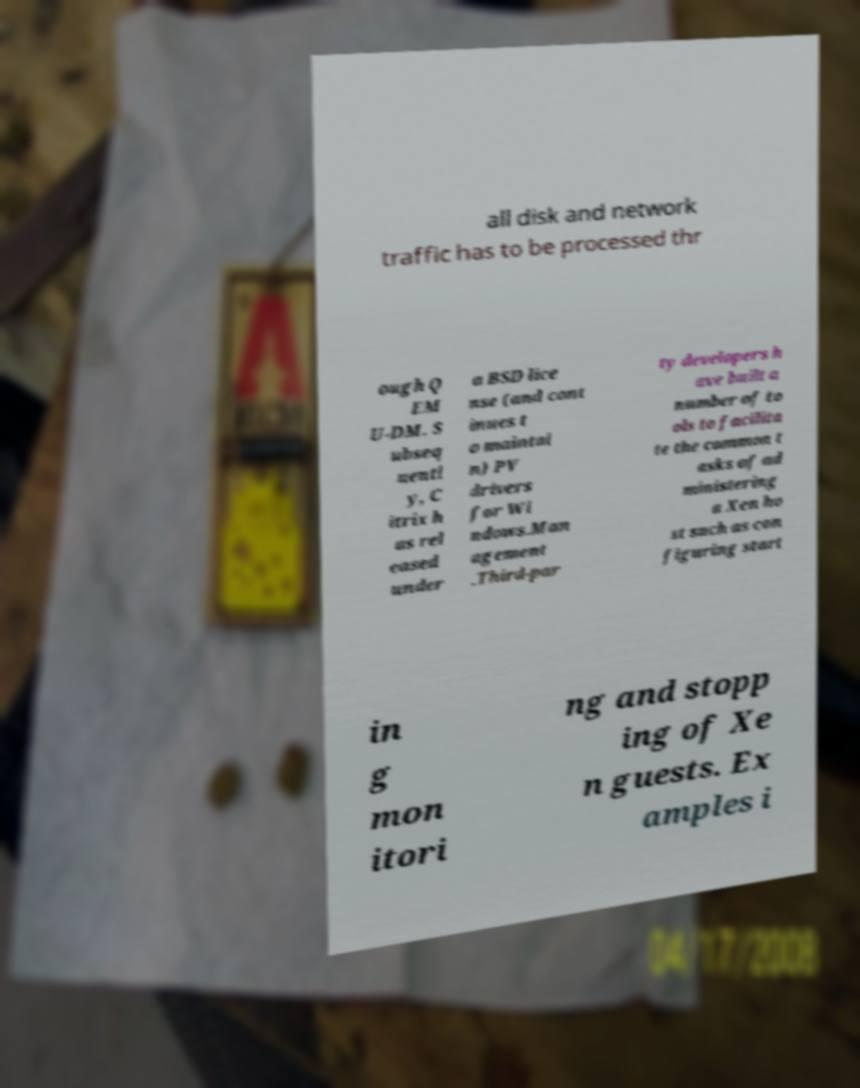I need the written content from this picture converted into text. Can you do that? all disk and network traffic has to be processed thr ough Q EM U-DM. S ubseq uentl y, C itrix h as rel eased under a BSD lice nse (and cont inues t o maintai n) PV drivers for Wi ndows.Man agement .Third-par ty developers h ave built a number of to ols to facilita te the common t asks of ad ministering a Xen ho st such as con figuring start in g mon itori ng and stopp ing of Xe n guests. Ex amples i 